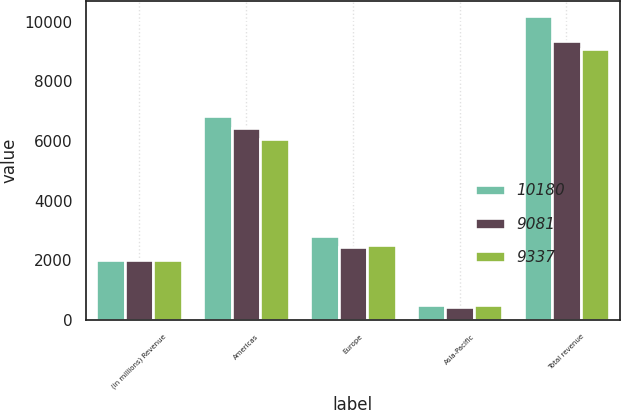<chart> <loc_0><loc_0><loc_500><loc_500><stacked_bar_chart><ecel><fcel>(in millions) Revenue<fcel>Americas<fcel>Europe<fcel>Asia-Pacific<fcel>Total revenue<nl><fcel>10180<fcel>2013<fcel>6829<fcel>2832<fcel>519<fcel>10180<nl><fcel>9081<fcel>2012<fcel>6429<fcel>2460<fcel>448<fcel>9337<nl><fcel>9337<fcel>2011<fcel>6064<fcel>2517<fcel>500<fcel>9081<nl></chart> 